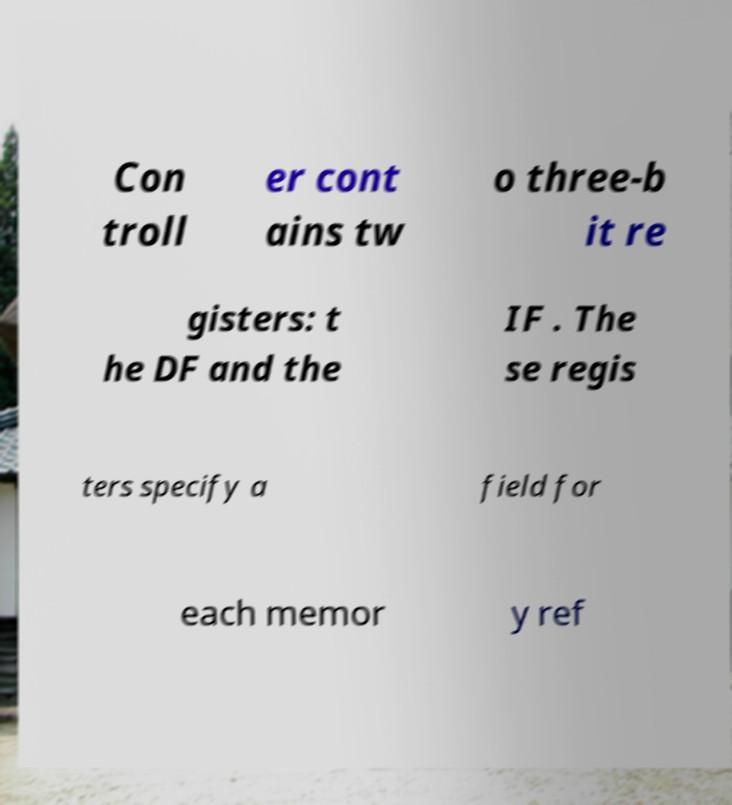I need the written content from this picture converted into text. Can you do that? Con troll er cont ains tw o three-b it re gisters: t he DF and the IF . The se regis ters specify a field for each memor y ref 